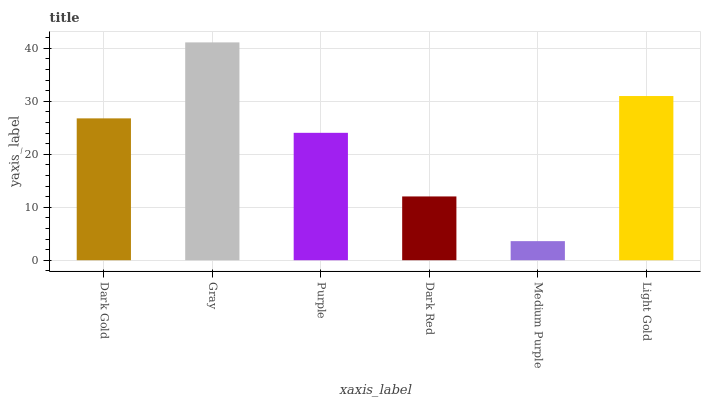Is Medium Purple the minimum?
Answer yes or no. Yes. Is Gray the maximum?
Answer yes or no. Yes. Is Purple the minimum?
Answer yes or no. No. Is Purple the maximum?
Answer yes or no. No. Is Gray greater than Purple?
Answer yes or no. Yes. Is Purple less than Gray?
Answer yes or no. Yes. Is Purple greater than Gray?
Answer yes or no. No. Is Gray less than Purple?
Answer yes or no. No. Is Dark Gold the high median?
Answer yes or no. Yes. Is Purple the low median?
Answer yes or no. Yes. Is Gray the high median?
Answer yes or no. No. Is Dark Gold the low median?
Answer yes or no. No. 